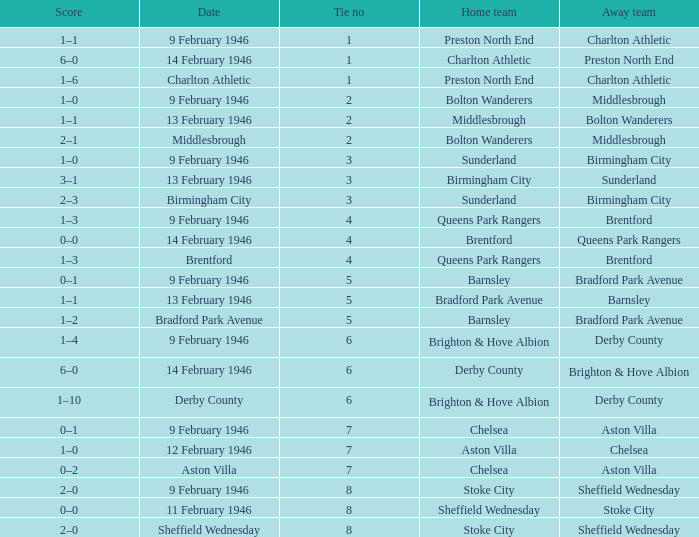What is the average Tie no when the date is Birmingham City? 3.0. 